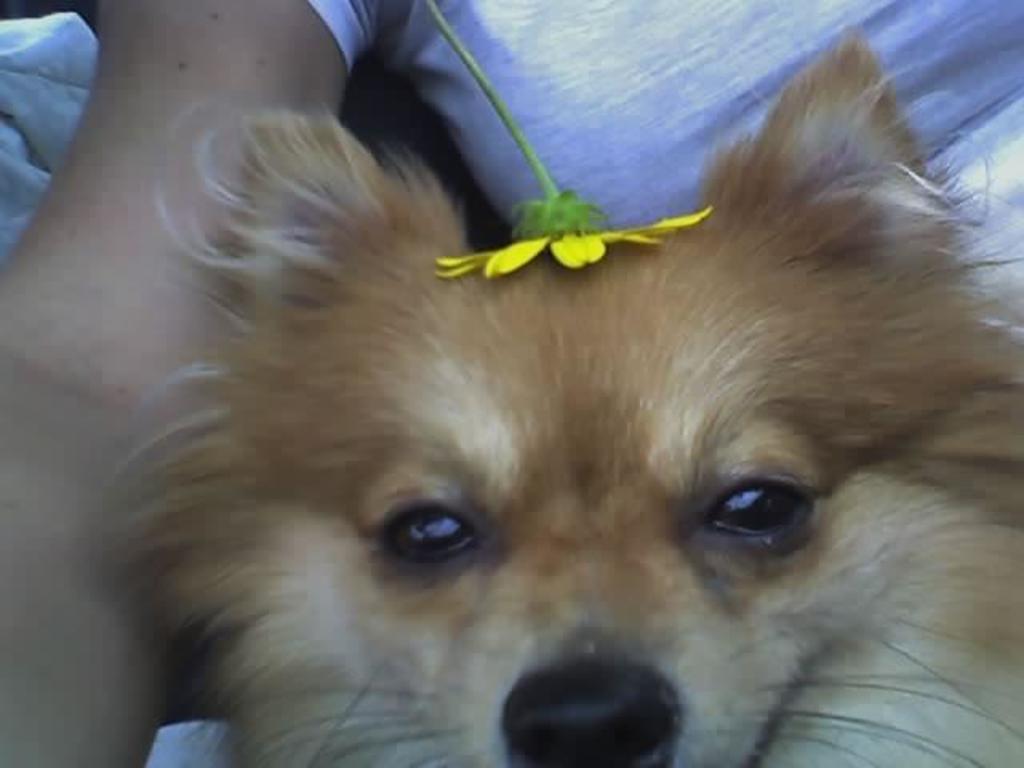Can you describe this image briefly? In front of the picture, we see the brown dog. We can only see the eyes, ears and nose of the dog. We see the yellow flower is on its head. In the background, we see the person is wearing the white T-shirt. In the left top, we see a cloth in white color. 